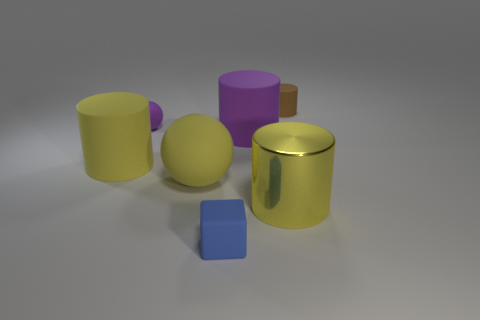Add 3 small blue rubber things. How many objects exist? 10 Subtract all blocks. How many objects are left? 6 Add 5 small brown cylinders. How many small brown cylinders are left? 6 Add 1 large blue rubber blocks. How many large blue rubber blocks exist? 1 Subtract 1 purple balls. How many objects are left? 6 Subtract all small matte balls. Subtract all large yellow balls. How many objects are left? 5 